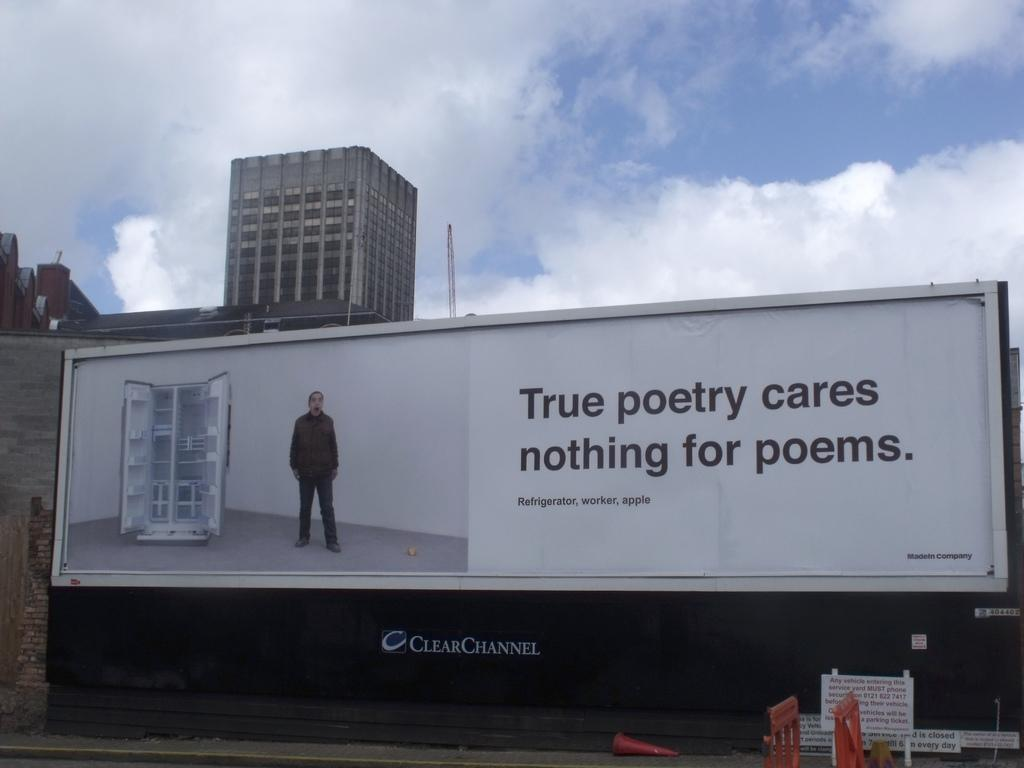<image>
Share a concise interpretation of the image provided. A billboard for ClearChannel reads "Refrigerator, worker apple" 